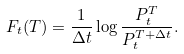Convert formula to latex. <formula><loc_0><loc_0><loc_500><loc_500>F _ { t } ( T ) = \frac { 1 } { \Delta t } \log \frac { P ^ { T } _ { t } } { P ^ { T + \Delta t } _ { t } } .</formula> 